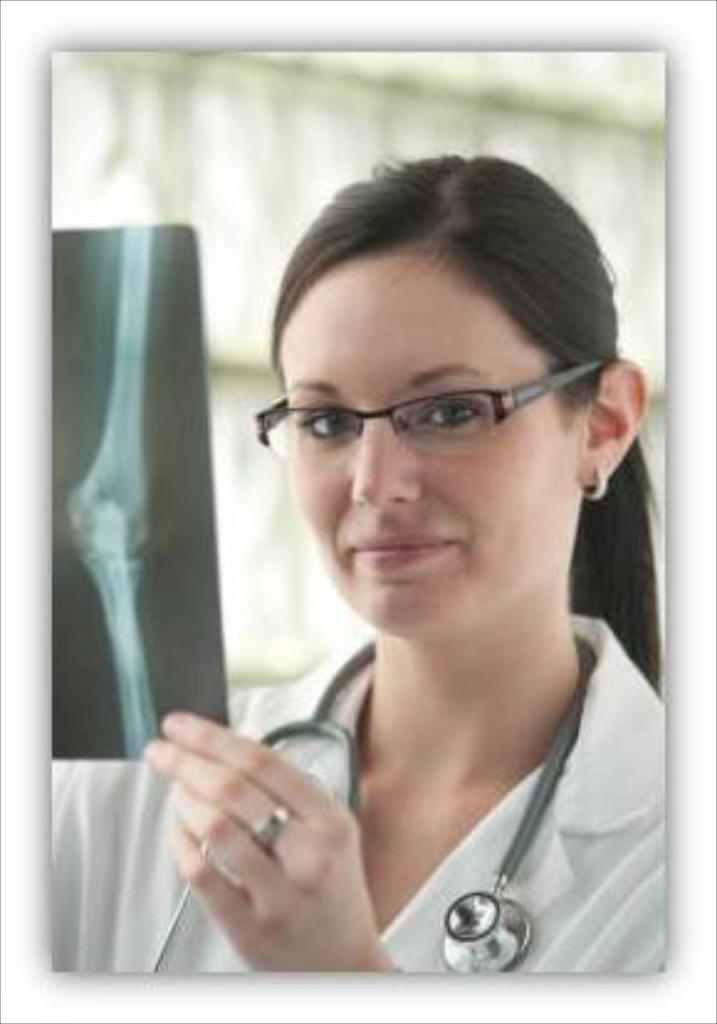What is the person in the image holding? The person is holding an x-ray sheet. What type of clothing is the person wearing? The person is wearing a white coat. What medical tool is the person wearing? The person is wearing a stethoscope. What is the color of the background in the image? The background of the image is white. What type of toothbrush is the scarecrow using in the image? There is no toothbrush or scarecrow present in the image. Can you compare the person's stethoscope to another stethoscope in the image? There is only one stethoscope visible in the image, so it cannot be compared to another stethoscope. 